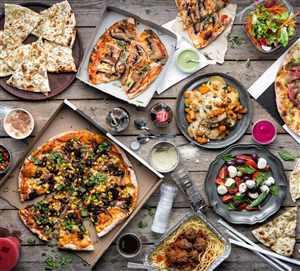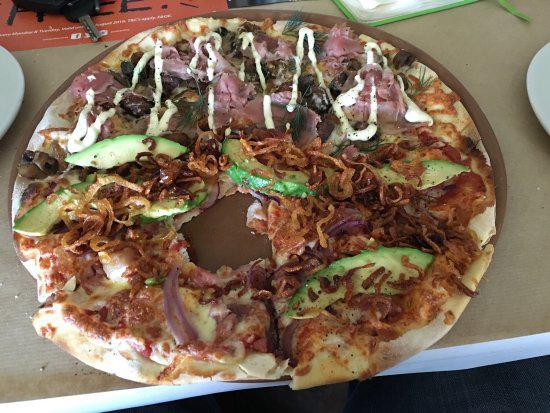The first image is the image on the left, the second image is the image on the right. For the images shown, is this caption "The left image includes at least two round platters of food and at least one small condiment cup next to a sliced pizza on a brown plank surface." true? Answer yes or no. Yes. The first image is the image on the left, the second image is the image on the right. Considering the images on both sides, is "Part of a pizza is missing." valid? Answer yes or no. Yes. 